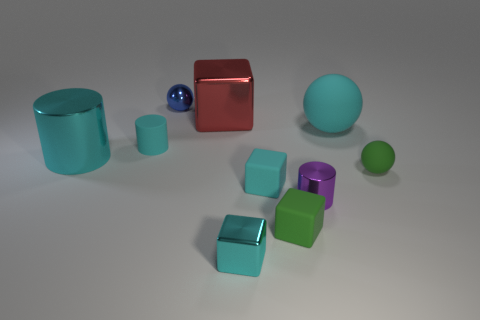What number of tiny cylinders are on the right side of the green thing that is in front of the rubber ball in front of the cyan rubber sphere?
Provide a short and direct response. 1. Are there any other things that are the same material as the large red block?
Your answer should be very brief. Yes. Are there fewer cyan metallic blocks that are on the left side of the blue object than large yellow shiny blocks?
Ensure brevity in your answer.  No. Do the small rubber cylinder and the big rubber object have the same color?
Give a very brief answer. Yes. There is a green object that is the same shape as the red object; what size is it?
Your answer should be very brief. Small. How many tiny blue spheres have the same material as the large red block?
Your answer should be compact. 1. Is the material of the large cylinder to the left of the tiny shiny ball the same as the small purple cylinder?
Offer a terse response. Yes. Are there the same number of large blocks that are in front of the cyan matte ball and cyan cylinders?
Ensure brevity in your answer.  No. How big is the green matte block?
Your answer should be compact. Small. What is the material of the other large cylinder that is the same color as the rubber cylinder?
Keep it short and to the point. Metal. 